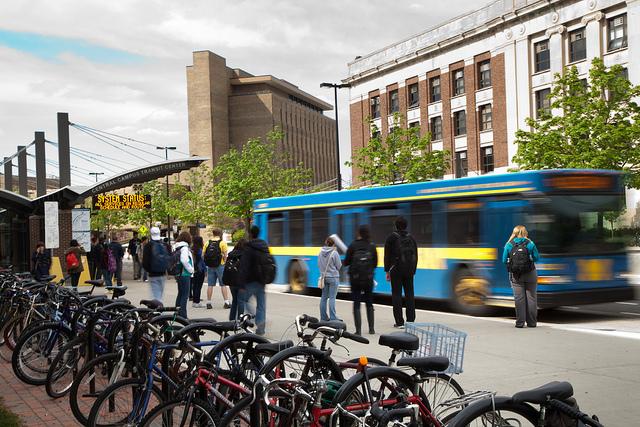Is anyone riding a bicycle?
Answer briefly. No. Why is the bus out of focus in this photograph?
Concise answer only. Moving. What color is the bus?
Be succinct. Blue. Are there bicycles in the picture?
Write a very short answer. Yes. 